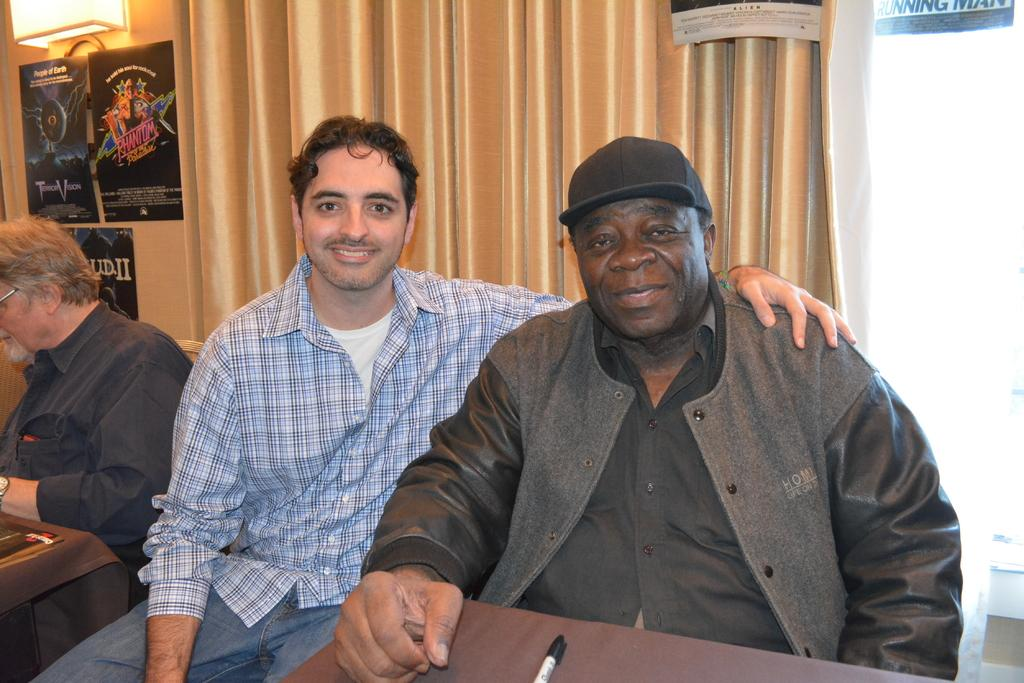What are the people in the image doing? There are persons sitting at the table in the image. What object can be seen on the table? There is a marker on the table. What can be seen in the background of the image? There is a certain (possibly a type of object or structure) in the background, as well as posts, a light, and a wall. How many sisters are present in the image? There is no mention of sisters in the image, so we cannot determine the number of sisters present. 